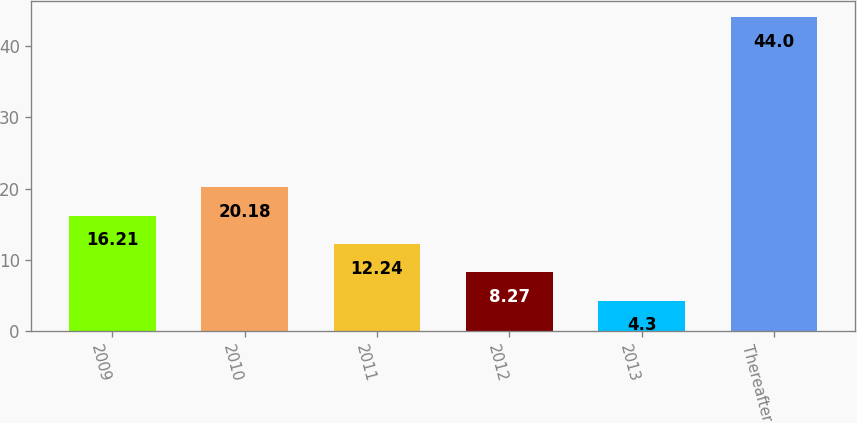Convert chart to OTSL. <chart><loc_0><loc_0><loc_500><loc_500><bar_chart><fcel>2009<fcel>2010<fcel>2011<fcel>2012<fcel>2013<fcel>Thereafter<nl><fcel>16.21<fcel>20.18<fcel>12.24<fcel>8.27<fcel>4.3<fcel>44<nl></chart> 